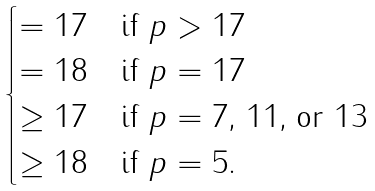<formula> <loc_0><loc_0><loc_500><loc_500>\begin{cases} = 1 7 & \text {if $p>17$} \\ = 1 8 & \text {if $p=17$} \\ \geq 1 7 & \text {if $p=7$, 11, or 13} \\ \geq 1 8 & \text {if $p=5$.} \end{cases}</formula> 